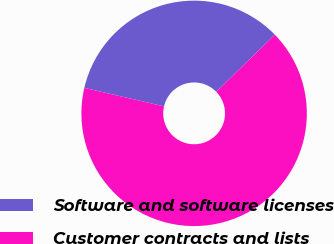Convert chart. <chart><loc_0><loc_0><loc_500><loc_500><pie_chart><fcel>Software and software licenses<fcel>Customer contracts and lists<nl><fcel>34.08%<fcel>65.92%<nl></chart> 